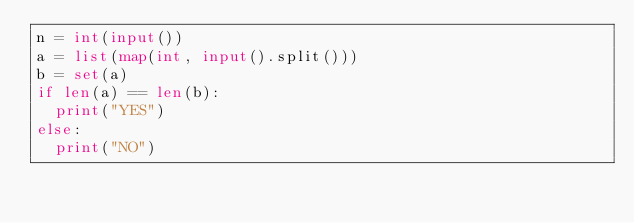<code> <loc_0><loc_0><loc_500><loc_500><_Python_>n = int(input())
a = list(map(int, input().split()))
b = set(a)
if len(a) == len(b):
  print("YES")
else:
  print("NO")</code> 